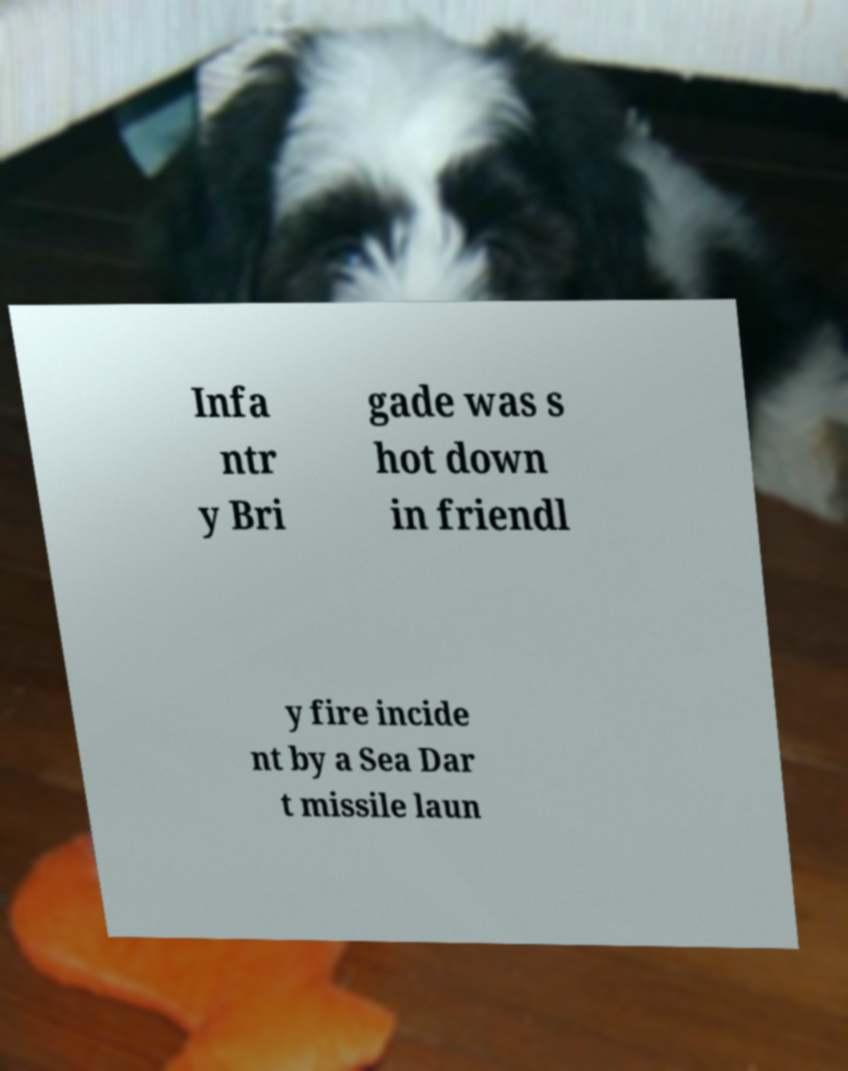For documentation purposes, I need the text within this image transcribed. Could you provide that? Infa ntr y Bri gade was s hot down in friendl y fire incide nt by a Sea Dar t missile laun 